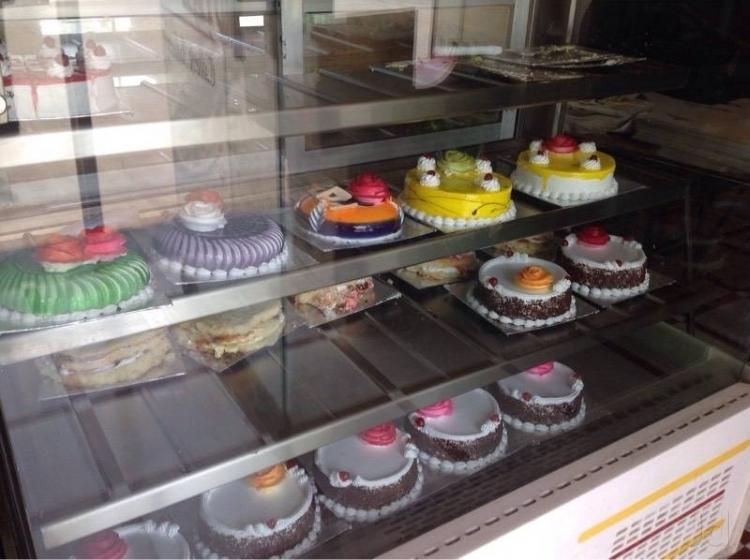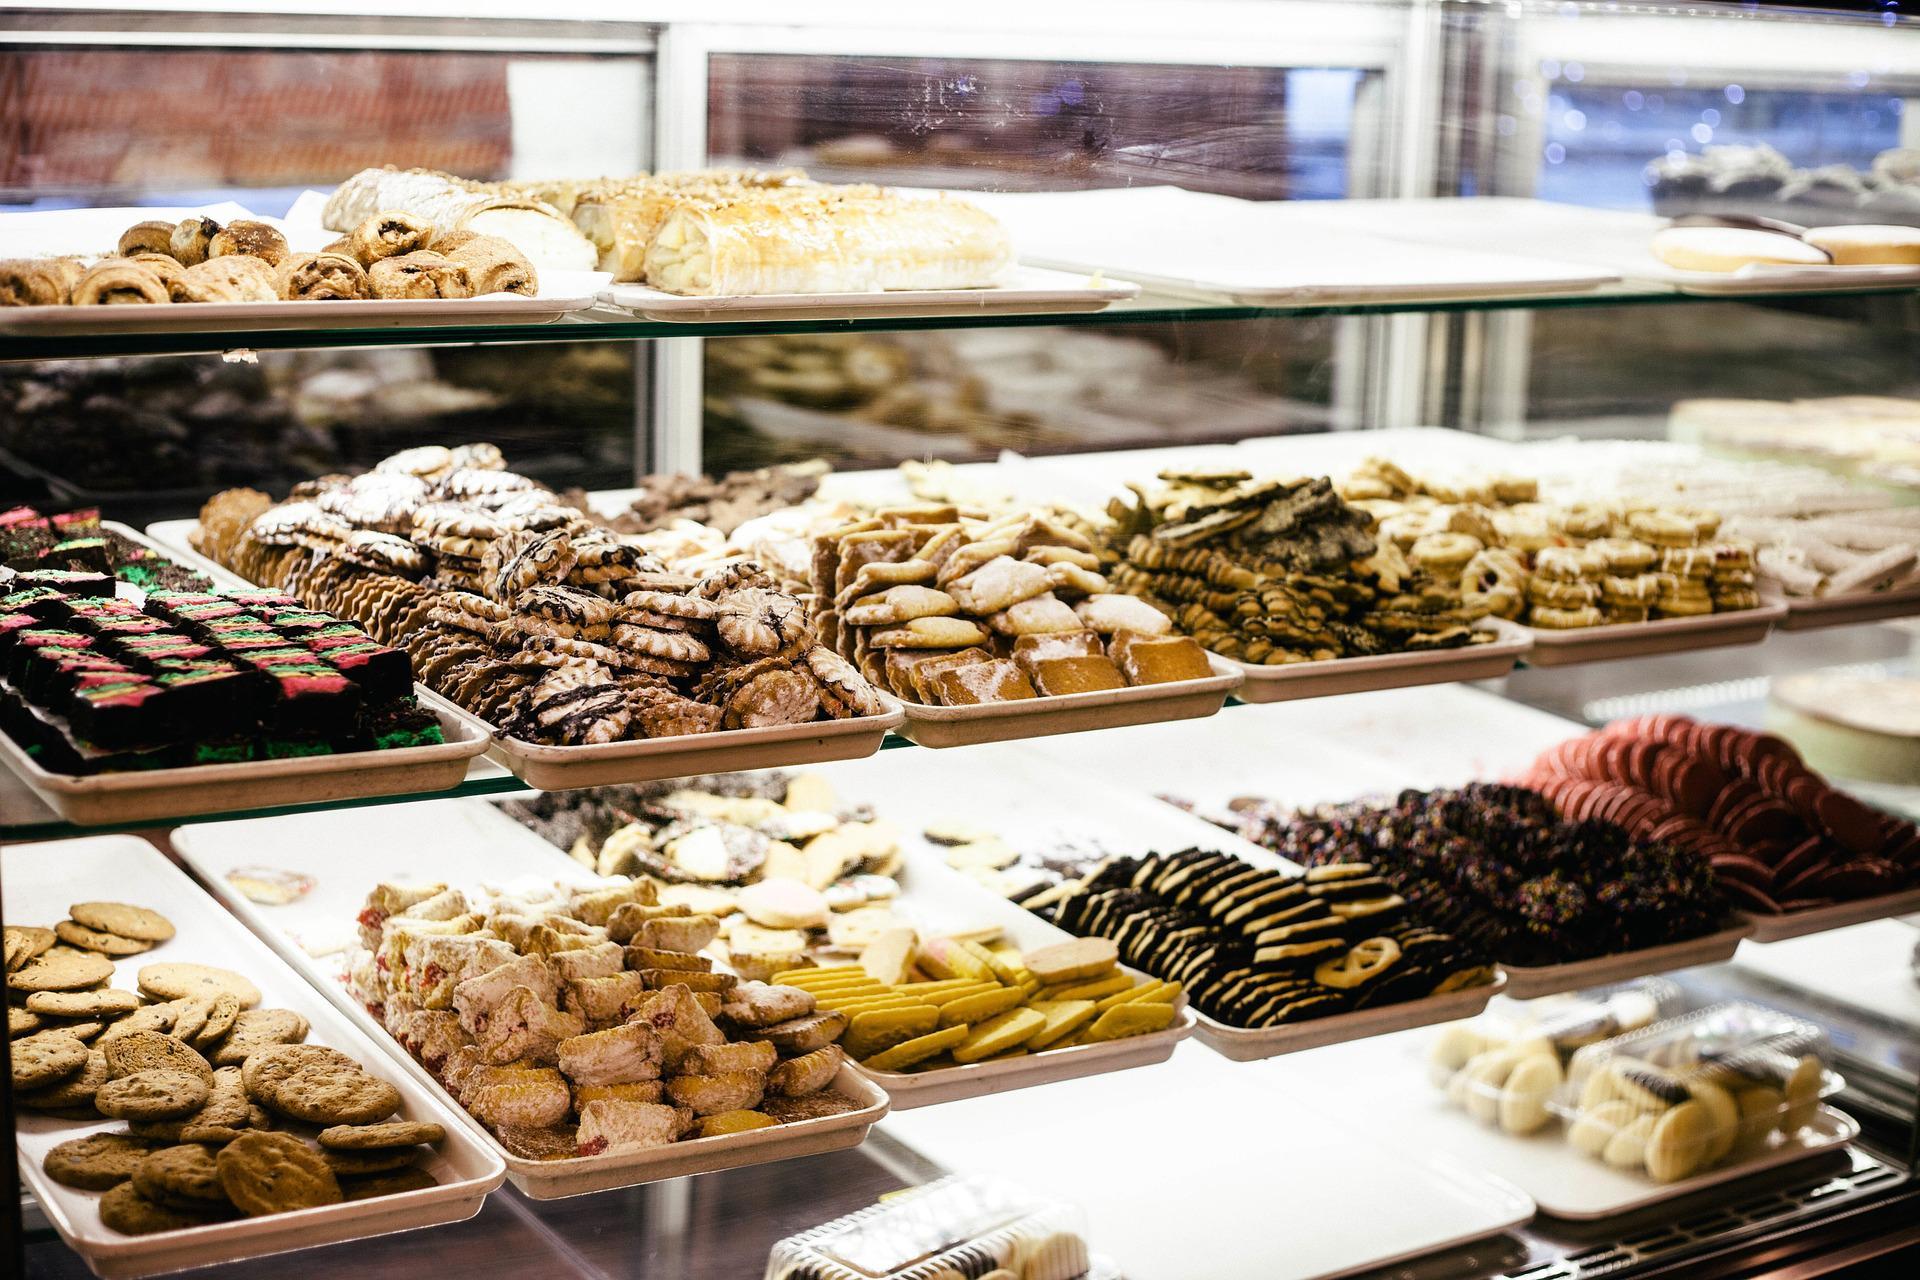The first image is the image on the left, the second image is the image on the right. For the images displayed, is the sentence "Floral arrangements are on a shelf somewhere above a glass display of bakery items." factually correct? Answer yes or no. No. The first image is the image on the left, the second image is the image on the right. Examine the images to the left and right. Is the description "There are labels for each group of pastries in at least one of the images." accurate? Answer yes or no. No. 